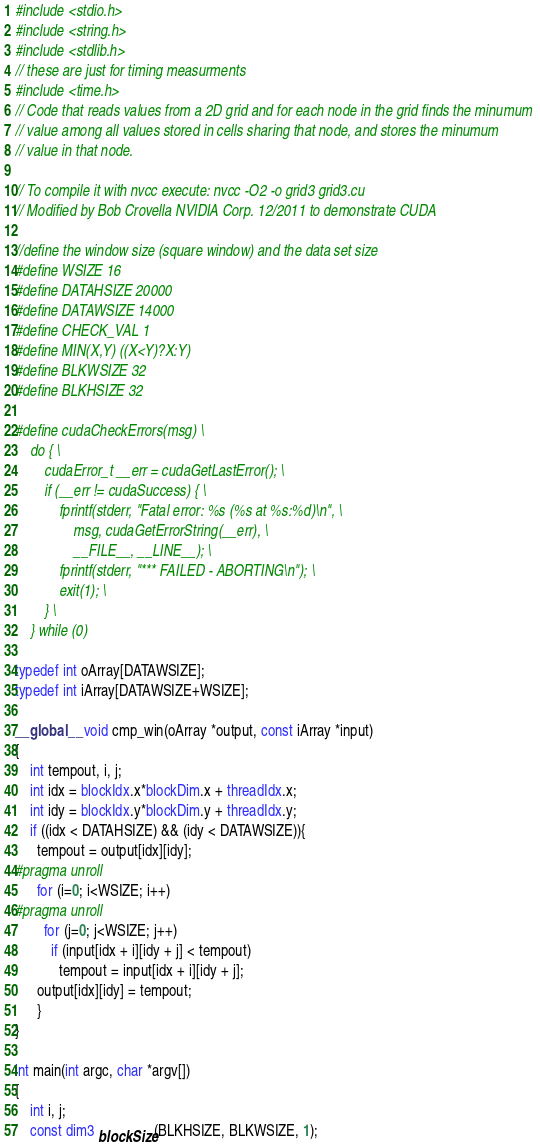<code> <loc_0><loc_0><loc_500><loc_500><_Cuda_>#include <stdio.h>
#include <string.h>
#include <stdlib.h>
// these are just for timing measurments
#include <time.h>
// Code that reads values from a 2D grid and for each node in the grid finds the minumum 
// value among all values stored in cells sharing that node, and stores the minumum 
// value in that node.

// To compile it with nvcc execute: nvcc -O2 -o grid3 grid3.cu
// Modified by Bob Crovella NVIDIA Corp. 12/2011 to demonstrate CUDA

//define the window size (square window) and the data set size
#define WSIZE 16 
#define DATAHSIZE 20000 
#define DATAWSIZE 14000
#define CHECK_VAL 1
#define MIN(X,Y) ((X<Y)?X:Y)
#define BLKWSIZE 32
#define BLKHSIZE 32

#define cudaCheckErrors(msg) \
    do { \
        cudaError_t __err = cudaGetLastError(); \
        if (__err != cudaSuccess) { \
            fprintf(stderr, "Fatal error: %s (%s at %s:%d)\n", \
                msg, cudaGetErrorString(__err), \
                __FILE__, __LINE__); \
            fprintf(stderr, "*** FAILED - ABORTING\n"); \
            exit(1); \
        } \
    } while (0)

typedef int oArray[DATAWSIZE];
typedef int iArray[DATAWSIZE+WSIZE];

__global__ void cmp_win(oArray *output, const iArray *input)
{
    int tempout, i, j;
    int idx = blockIdx.x*blockDim.x + threadIdx.x;
    int idy = blockIdx.y*blockDim.y + threadIdx.y;
    if ((idx < DATAHSIZE) && (idy < DATAWSIZE)){
      tempout = output[idx][idy];
#pragma unroll
      for (i=0; i<WSIZE; i++)
#pragma unroll
        for (j=0; j<WSIZE; j++)
          if (input[idx + i][idy + j] < tempout)
            tempout = input[idx + i][idy + j];
      output[idx][idy] = tempout;
      }
}

int main(int argc, char *argv[])
{
    int i, j;
    const dim3 blockSize(BLKHSIZE, BLKWSIZE, 1);</code> 